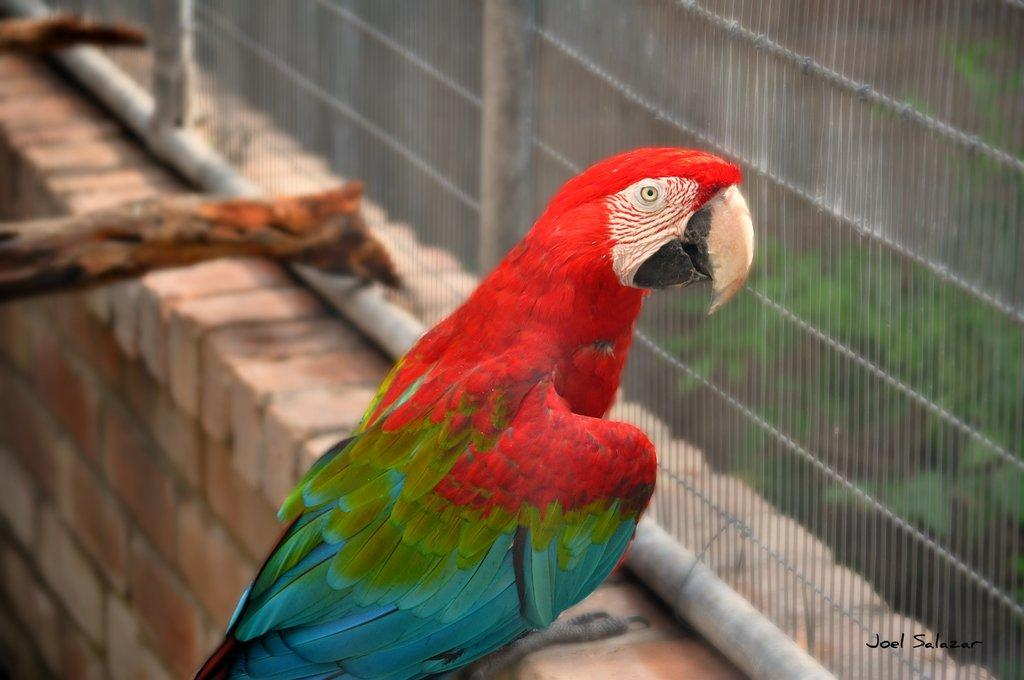What type of animal is in the image? There is a parrot in the image. Where is the parrot located? The parrot is sitting on a wall. What objects are beside the parrot? There are two wooden sticks beside the parrot. What is in front of the parrot? There is a closed mesh fencing in front of the parrot. What can be seen in the background of the image? A: There are trees in the background of the image. What type of mask is the actor wearing in the image? There is no actor or mask present in the image; it features a parrot sitting on a wall. What is the current status of the parrot in the image? The parrot is sitting on a wall, and there is no indication of its current status in the image. 